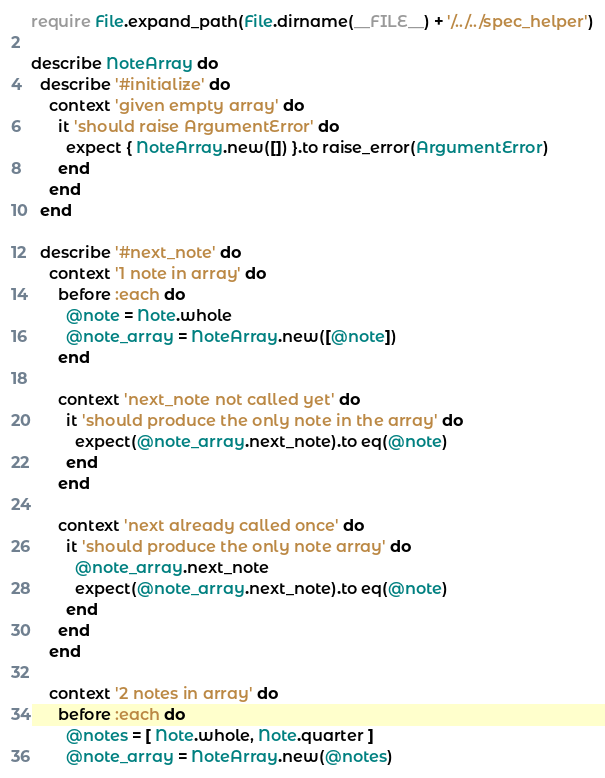<code> <loc_0><loc_0><loc_500><loc_500><_Ruby_>require File.expand_path(File.dirname(__FILE__) + '/../../spec_helper')

describe NoteArray do
  describe '#initialize' do
    context 'given empty array' do
      it 'should raise ArgumentError' do
        expect { NoteArray.new([]) }.to raise_error(ArgumentError)
      end
    end
  end

  describe '#next_note' do
    context '1 note in array' do
      before :each do
        @note = Note.whole
        @note_array = NoteArray.new([@note])
      end

      context 'next_note not called yet' do
        it 'should produce the only note in the array' do
          expect(@note_array.next_note).to eq(@note)
        end
      end

      context 'next already called once' do
        it 'should produce the only note array' do
          @note_array.next_note
          expect(@note_array.next_note).to eq(@note)
        end
      end
    end

    context '2 notes in array' do
      before :each do
        @notes = [ Note.whole, Note.quarter ]
        @note_array = NoteArray.new(@notes)</code> 